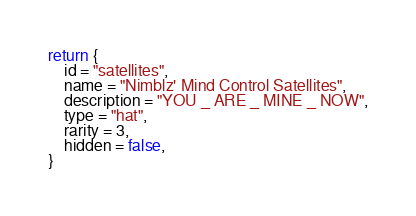Convert code to text. <code><loc_0><loc_0><loc_500><loc_500><_Lua_>return {
    id = "satellites",
    name = "Nimblz' Mind Control Satellites",
    description = "YOU _ ARE _ MINE _ NOW",
    type = "hat",
    rarity = 3,
    hidden = false,
}
</code> 